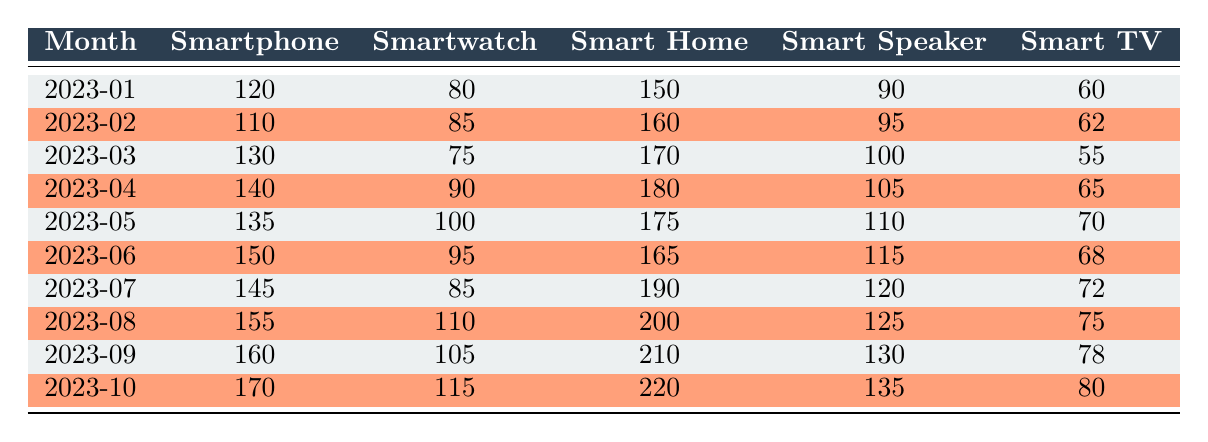What was the inventory level of smartphones in March 2023? In the table, we look for the row corresponding to March 2023, where the smartphone inventory is recorded. The smartphone inventory level for March 2023 is 130.
Answer: 130 How many smart TVs were available in August 2023? Searching the table for the row corresponding to August 2023, we find that the smart TV inventory level is listed as 75.
Answer: 75 Which month had the highest number of smart home devices? By examining the 'Smart Home' column, we see that the maximum value is 220, which corresponds to October 2023.
Answer: October 2023 What is the total inventory of smart speakers from June to October 2023? We sum the smart speaker inventories for June (115), July (120), August (125), September (130), and October (135). The total is 115 + 120 + 125 + 130 + 135 = 625.
Answer: 625 Is the number of smartwatches greater than 100 in any month? We review the smartwatch inventory for each month and find that it exceeds 100 in April (90), May (100), August (110), September (105), and October (115); hence, the statement is true.
Answer: Yes What was the average inventory level of smartphones from January to June 2023? We first add the smartphone inventories from January (120), February (110), March (130), April (140), May (135), and June (150). The total is 120 + 110 + 130 + 140 + 135 + 150 = 785. We then divide this total by 6 months to find the average: 785 / 6 ≈ 130.83.
Answer: Approximately 130.83 In which month did the inventory of smart home devices fall below 170? Reviewing the smart home devices inventory values, we see that only in January (150) and February (160) was the inventory below 170. This means that both these months meet the criteria, but January is the earliest.
Answer: January Which month has the highest total inventory when adding all types of smart devices together? To determine the month with the highest total, we calculate the sum of all inventory levels for each month. The totals are: January (120+80+150+90+60=500), February (110+85+160+95+62=512), March (130+75+170+100+55=530), April (140+90+180+105+65=680), May (135+100+175+110+70=690), June (150+95+165+115+68=693), July (145+85+190+120+72=702), August (155+110+200+125+75=715), September (160+105+210+130+78=683), October (170+115+220+135+80=720). The highest total is in August (715).
Answer: August 